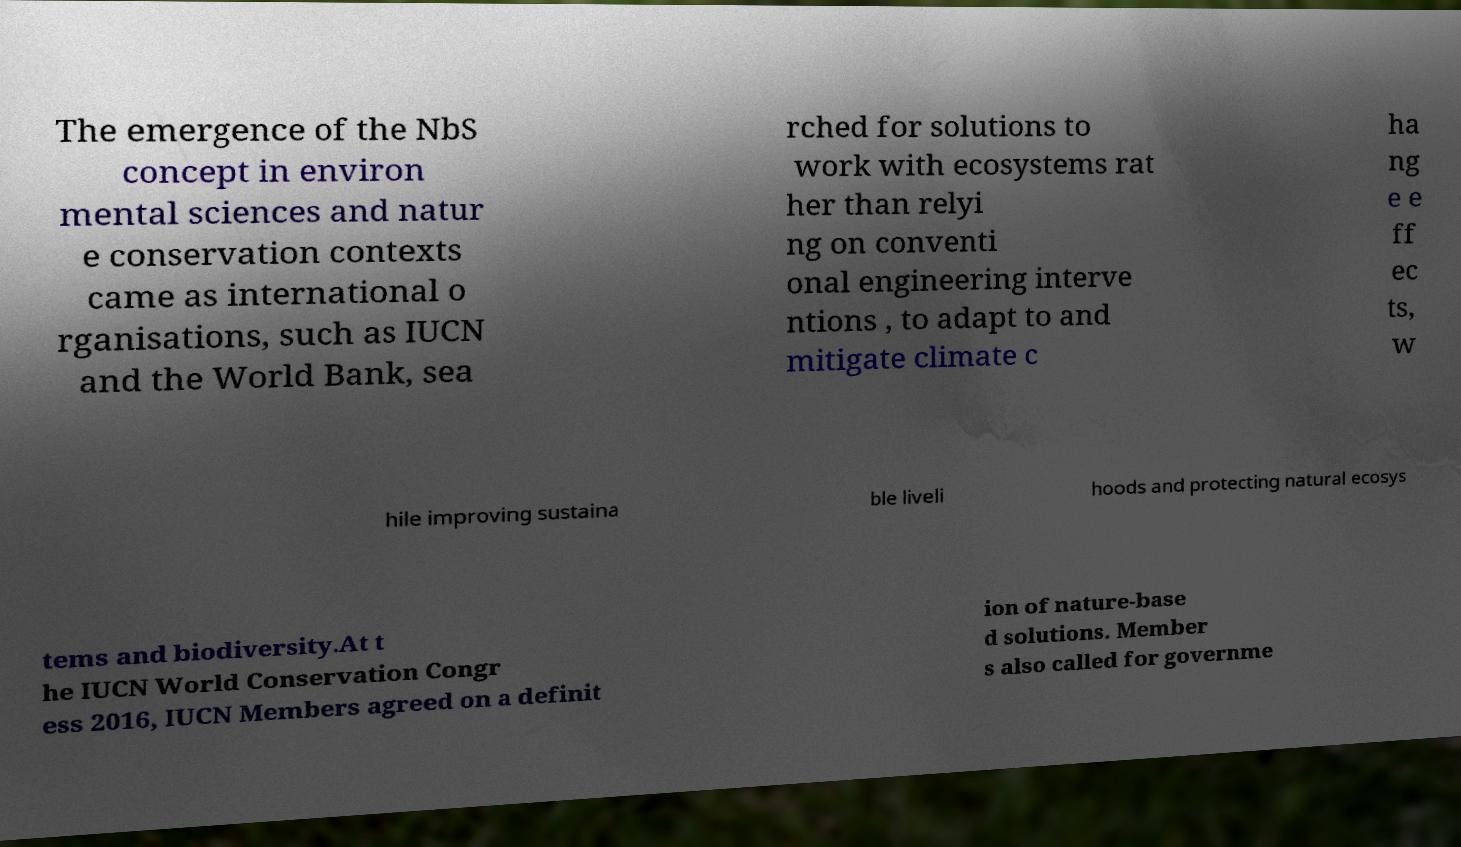I need the written content from this picture converted into text. Can you do that? The emergence of the NbS concept in environ mental sciences and natur e conservation contexts came as international o rganisations, such as IUCN and the World Bank, sea rched for solutions to work with ecosystems rat her than relyi ng on conventi onal engineering interve ntions , to adapt to and mitigate climate c ha ng e e ff ec ts, w hile improving sustaina ble liveli hoods and protecting natural ecosys tems and biodiversity.At t he IUCN World Conservation Congr ess 2016, IUCN Members agreed on a definit ion of nature-base d solutions. Member s also called for governme 